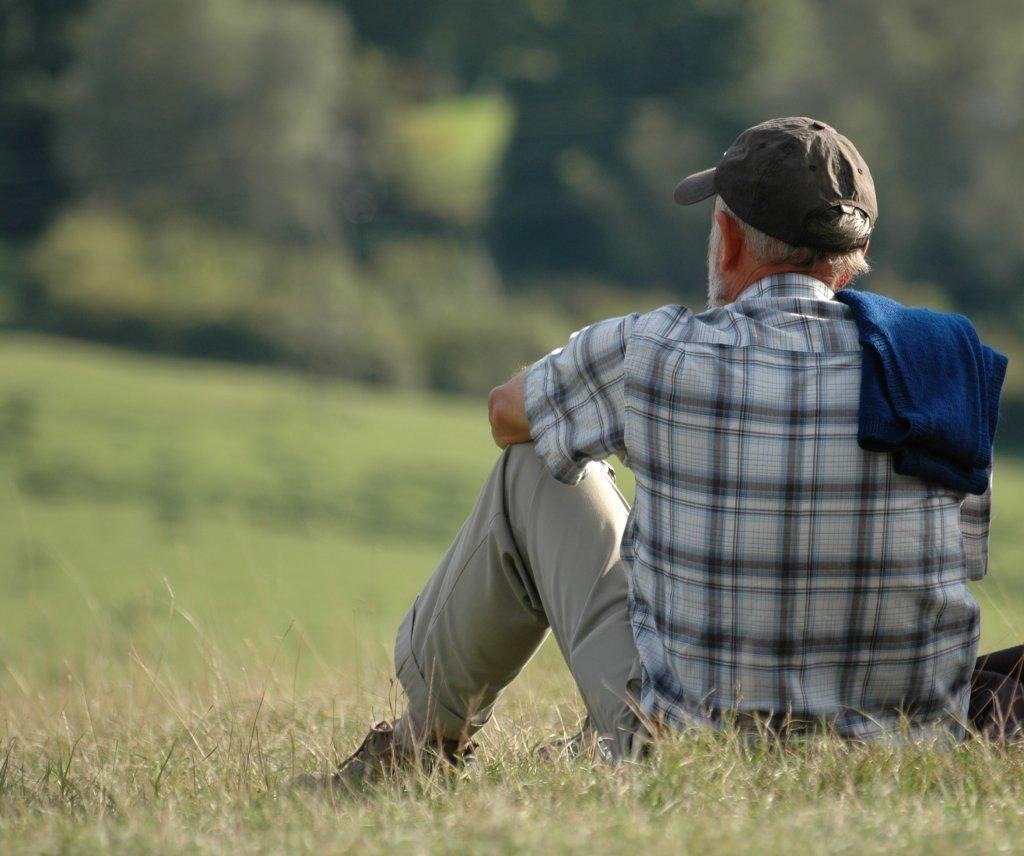What is the person in the image doing? The person is sitting on the grassy land. Where is the person located in the image? The person is on the right side of the image. What can be seen in the background of the image? There are trees in the background of the image. What type of library is depicted in the image? There is no library present in the image; it features a person sitting on grassy land with trees in the background. What word is being emphasized in the plot of the image? There is no plot or storyline in the image, as it is a simple scene of a person sitting on grassy land with trees in the background. 